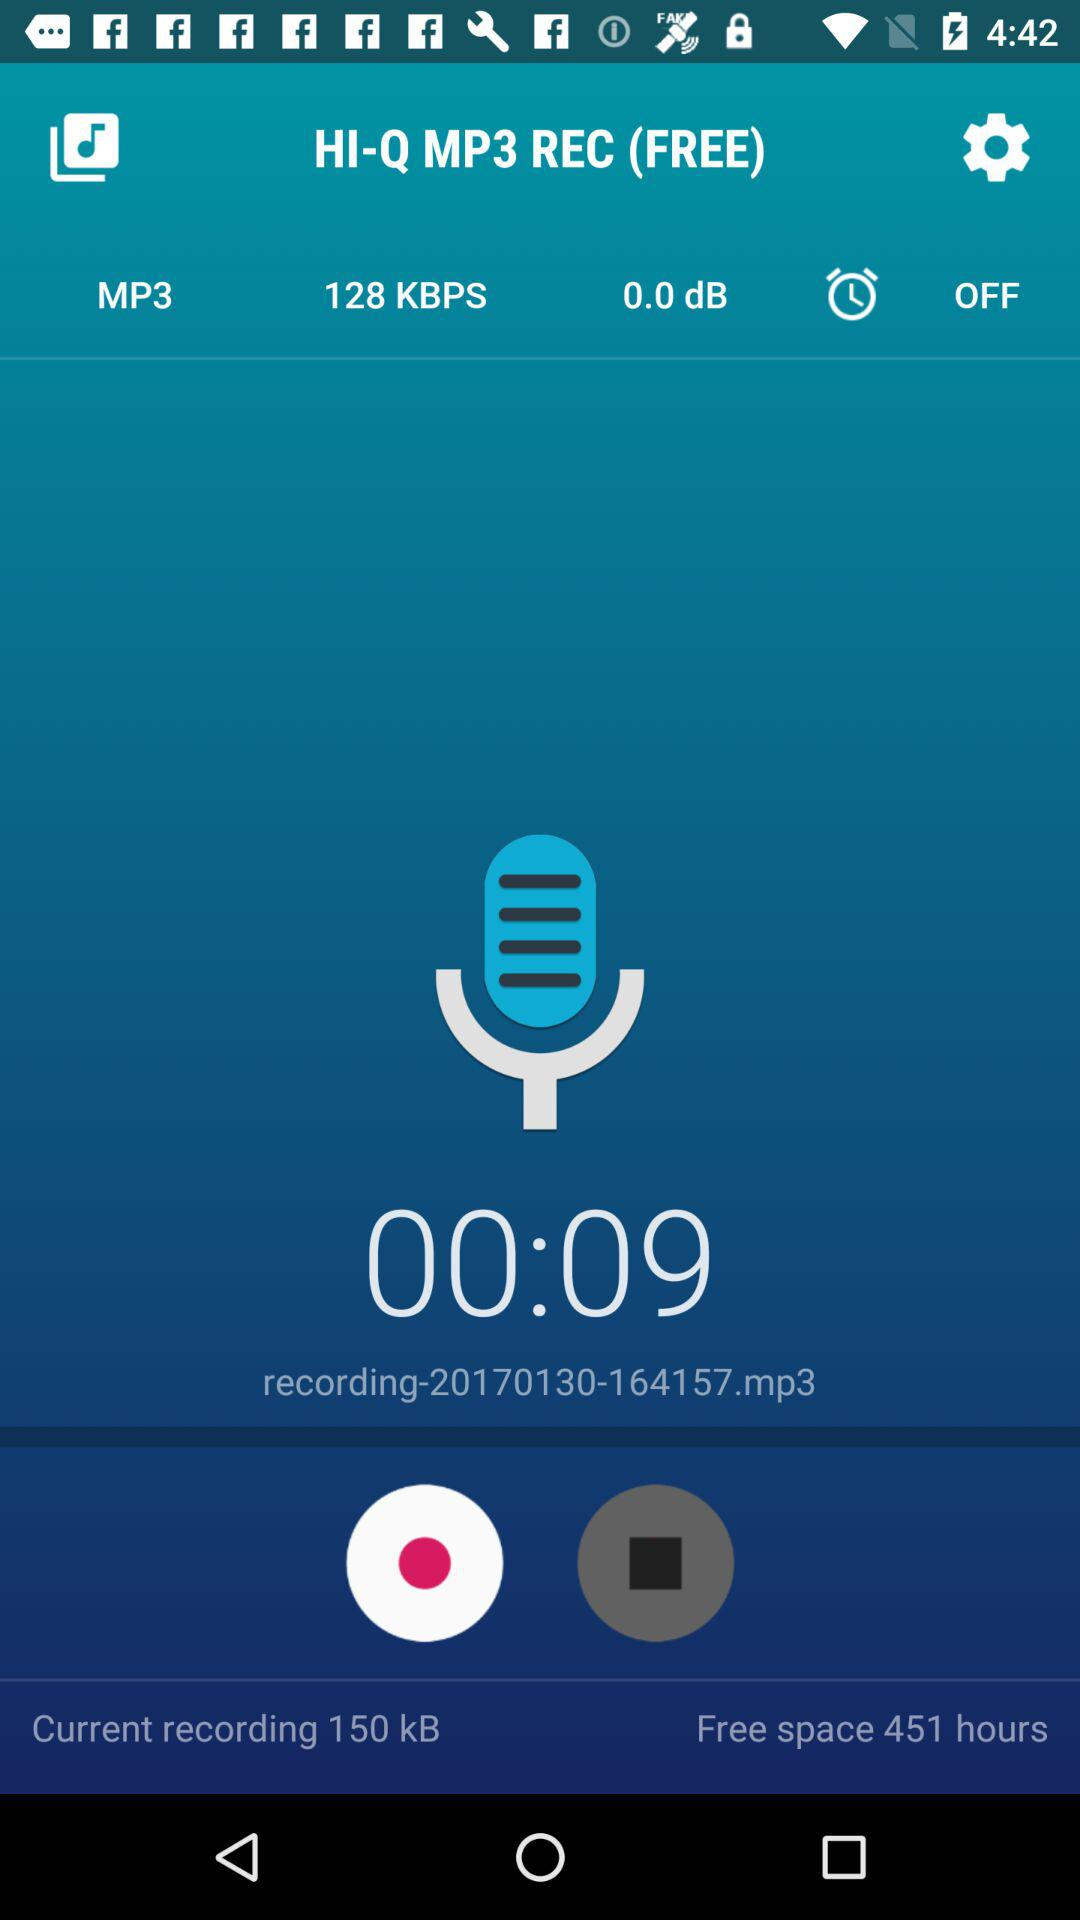What is the recording duration? The recording duration is 9 seconds. 